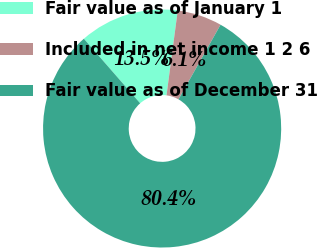Convert chart. <chart><loc_0><loc_0><loc_500><loc_500><pie_chart><fcel>Fair value as of January 1<fcel>Included in net income 1 2 6<fcel>Fair value as of December 31<nl><fcel>13.51%<fcel>6.07%<fcel>80.42%<nl></chart> 